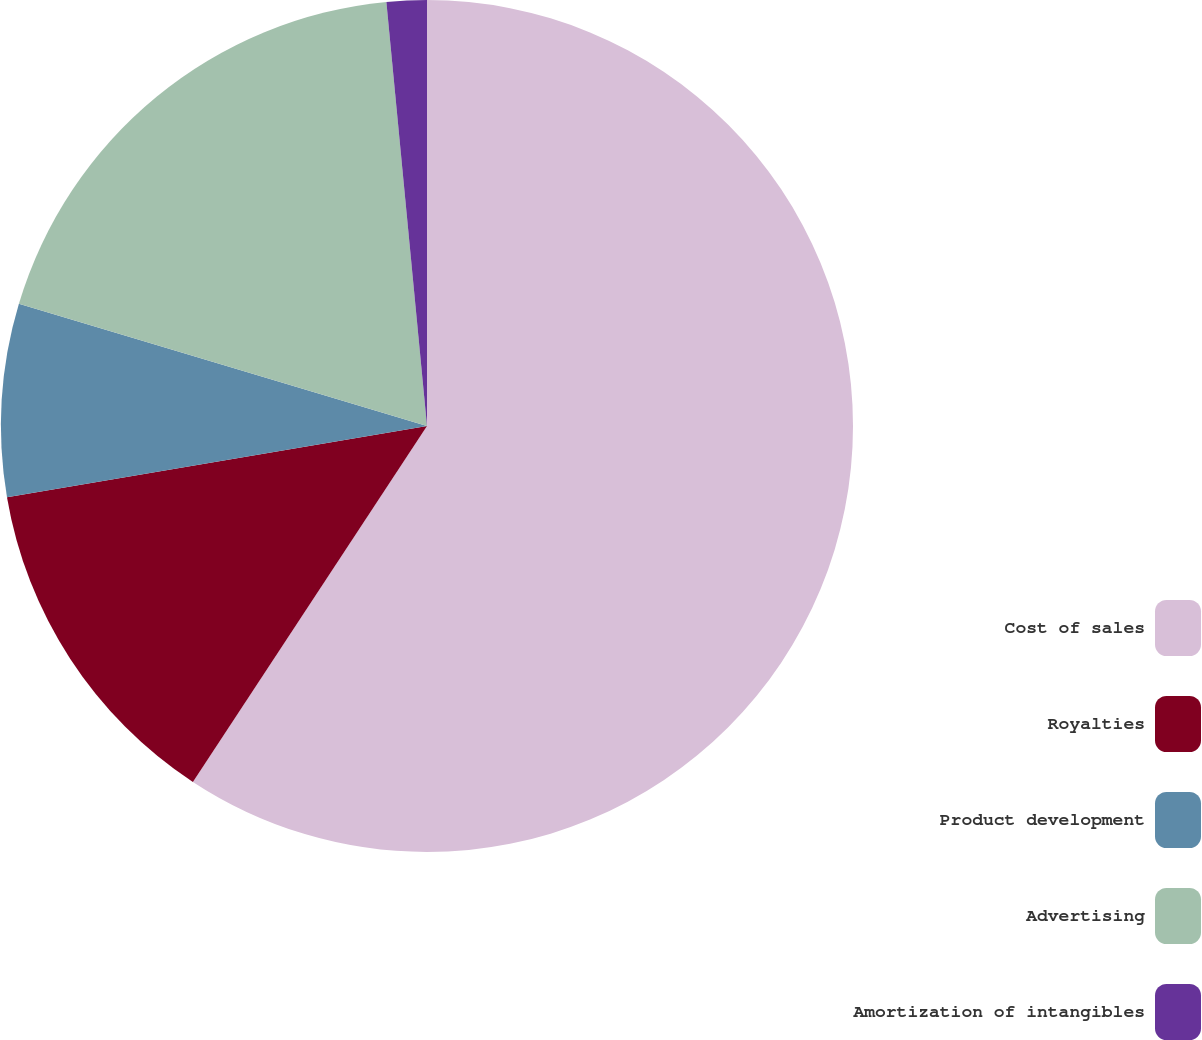<chart> <loc_0><loc_0><loc_500><loc_500><pie_chart><fcel>Cost of sales<fcel>Royalties<fcel>Product development<fcel>Advertising<fcel>Amortization of intangibles<nl><fcel>59.26%<fcel>13.07%<fcel>7.3%<fcel>18.85%<fcel>1.52%<nl></chart> 